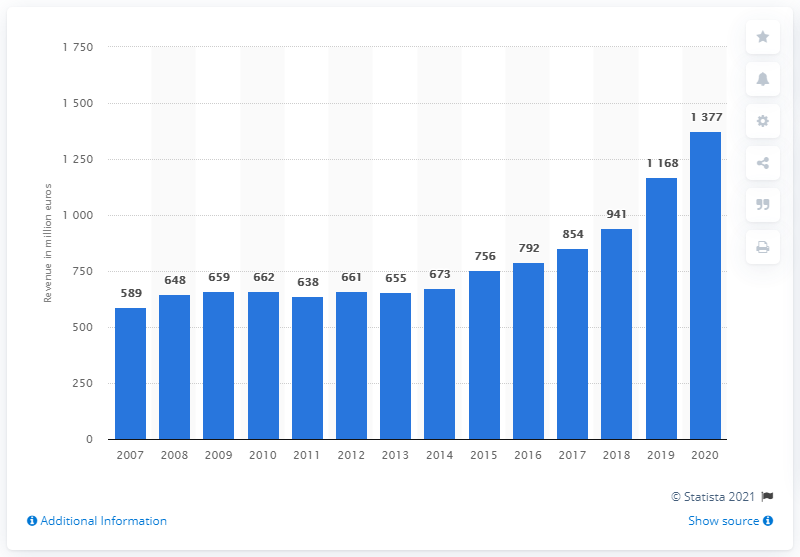Point out several critical features in this image. In 2020, the music publishing revenue of Universal Music Group reached a total of 1,377. 